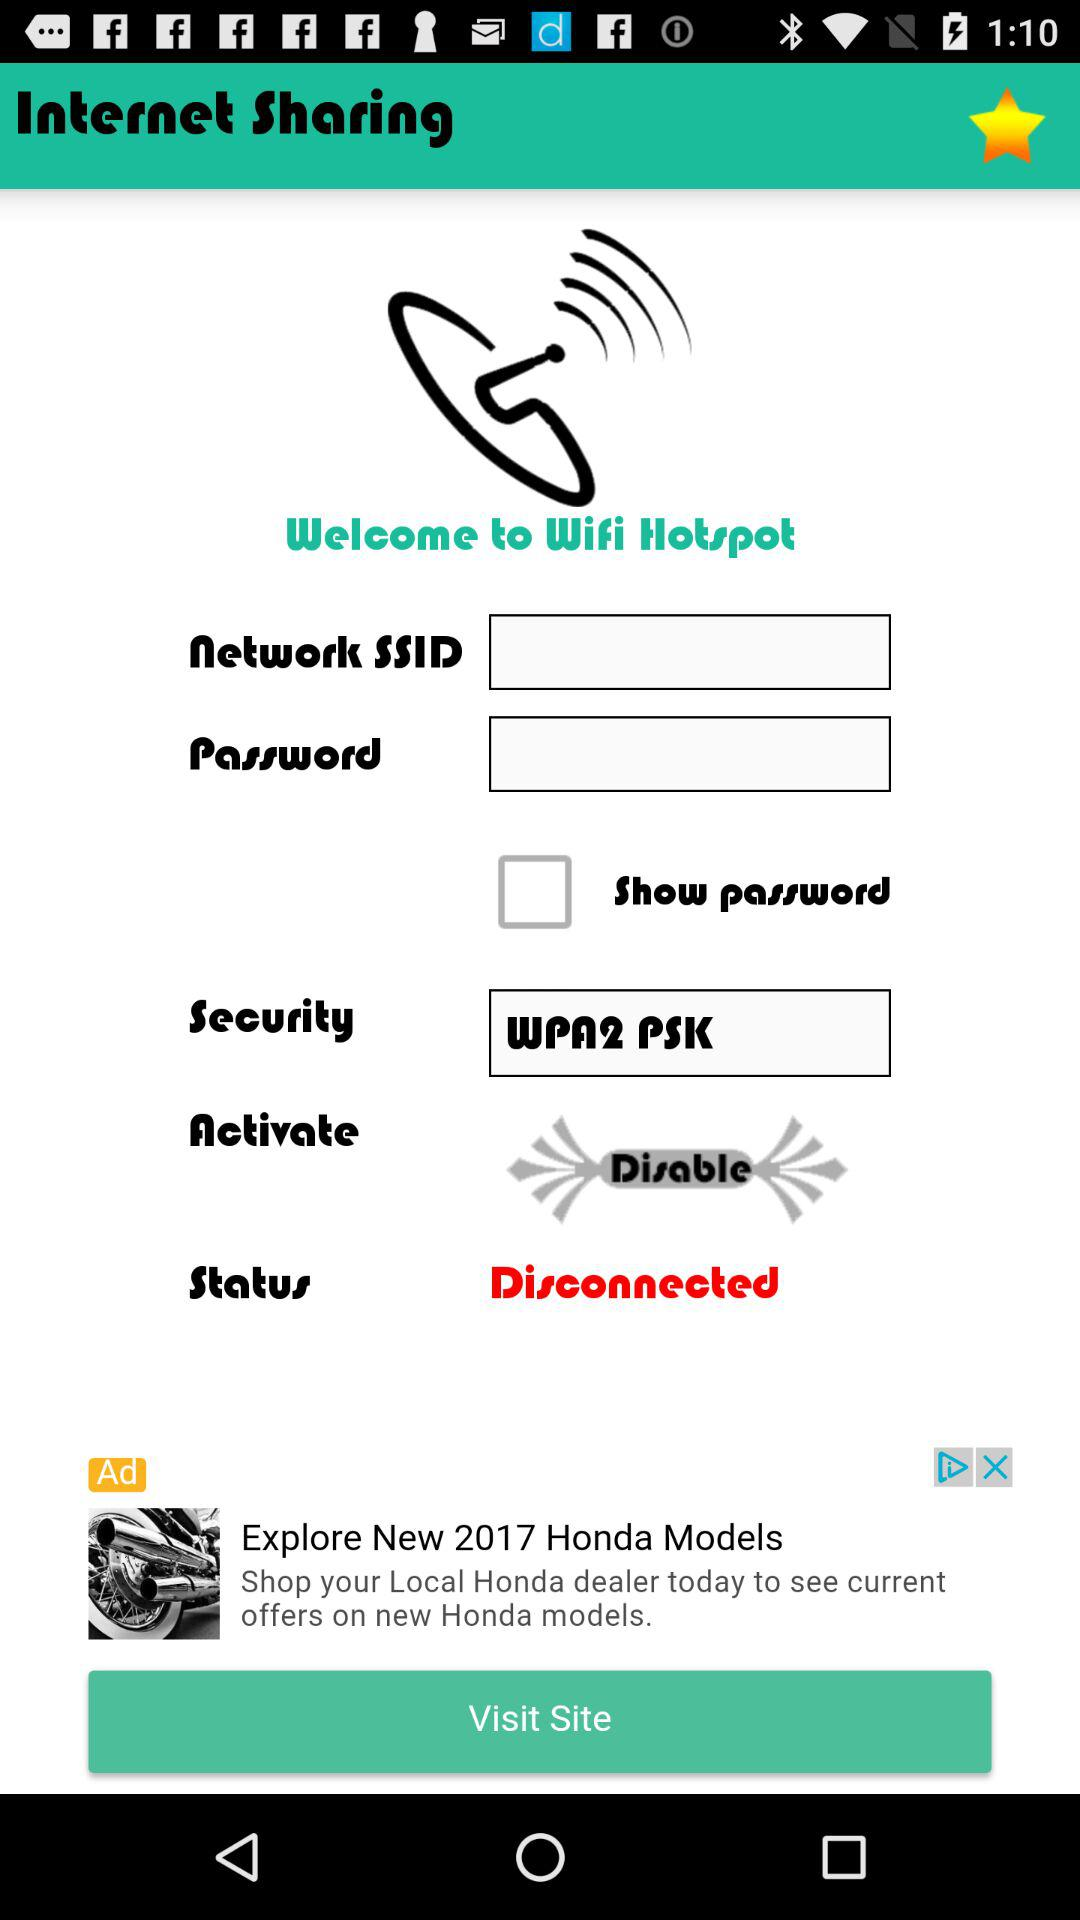What is the status of "Show password"? The status of "Show password" is "off". 